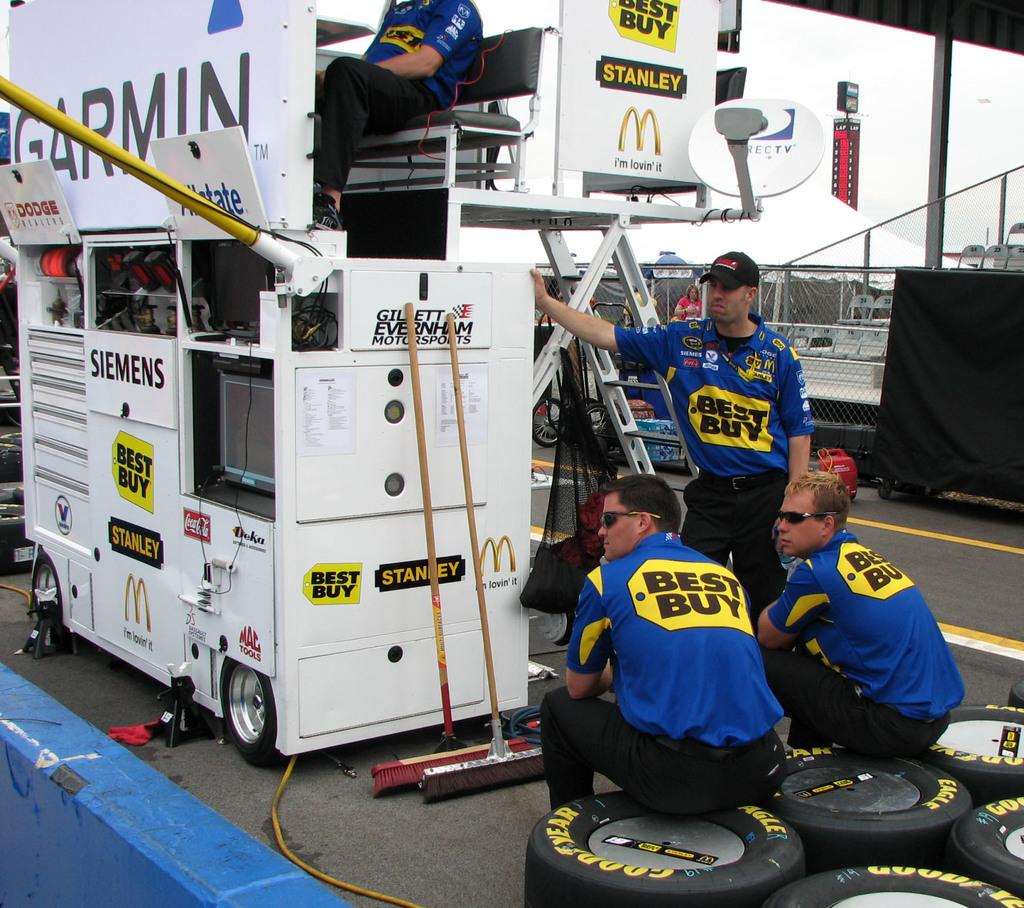How many people are in the image? There are people in the image, but the exact number is not specified. What objects are at the bottom of the image? There are tires at the bottom of the image. What tools are visible in the image? Brooms are visible in the image. What type of structure is present in the image? There is a booth in the image. What architectural feature can be seen in the image? There is a fence in the image. What part of the natural environment is visible in the image? The sky is visible in the image. What man-made object is present in the image? There is a pipe in the image. What type of recess can be seen in the image? There is no recess present in the image. What phase of the moon is visible in the image? The moon is not visible in the image; only the sky is visible. What type of bulb is illuminating the booth in the image? There is no bulb present in the image, and the booth's lighting is not mentioned. 